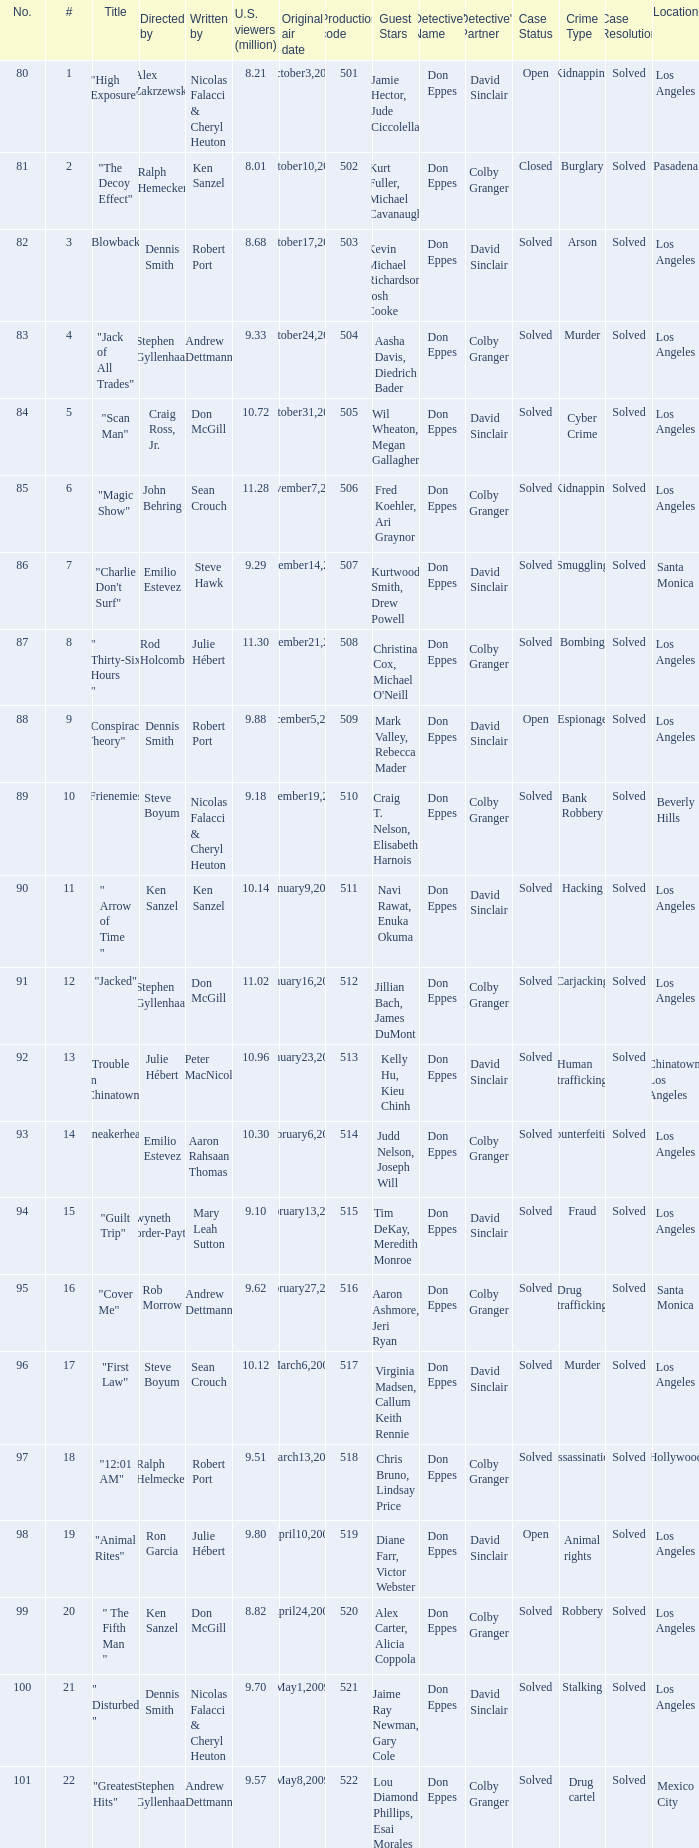What is the production code for the episode that had 9.18 million viewers (U.S.)? 510.0. 